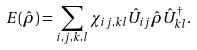Convert formula to latex. <formula><loc_0><loc_0><loc_500><loc_500>E ( \hat { \rho } ) = \sum _ { i , j , k , l } \chi _ { i j , k l } \hat { U } _ { i j } \hat { \rho } \hat { U } _ { k l } ^ { \dagger } .</formula> 